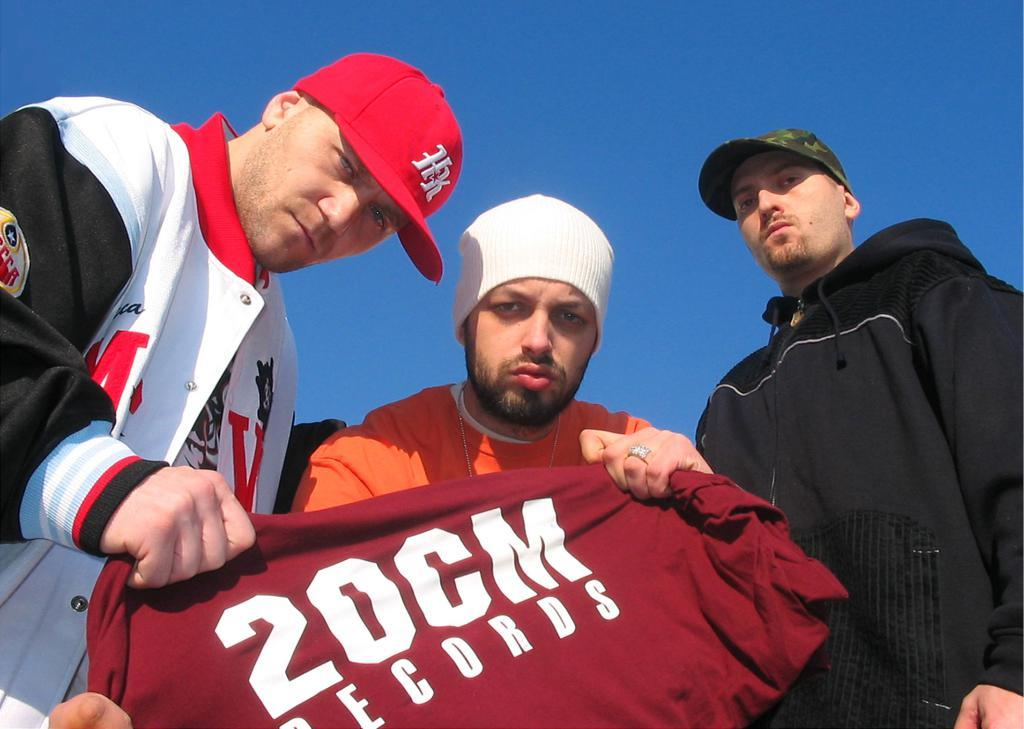<image>
Offer a succinct explanation of the picture presented. 3 white man with two of them holding a 2OCM Records shirt in front of them. 